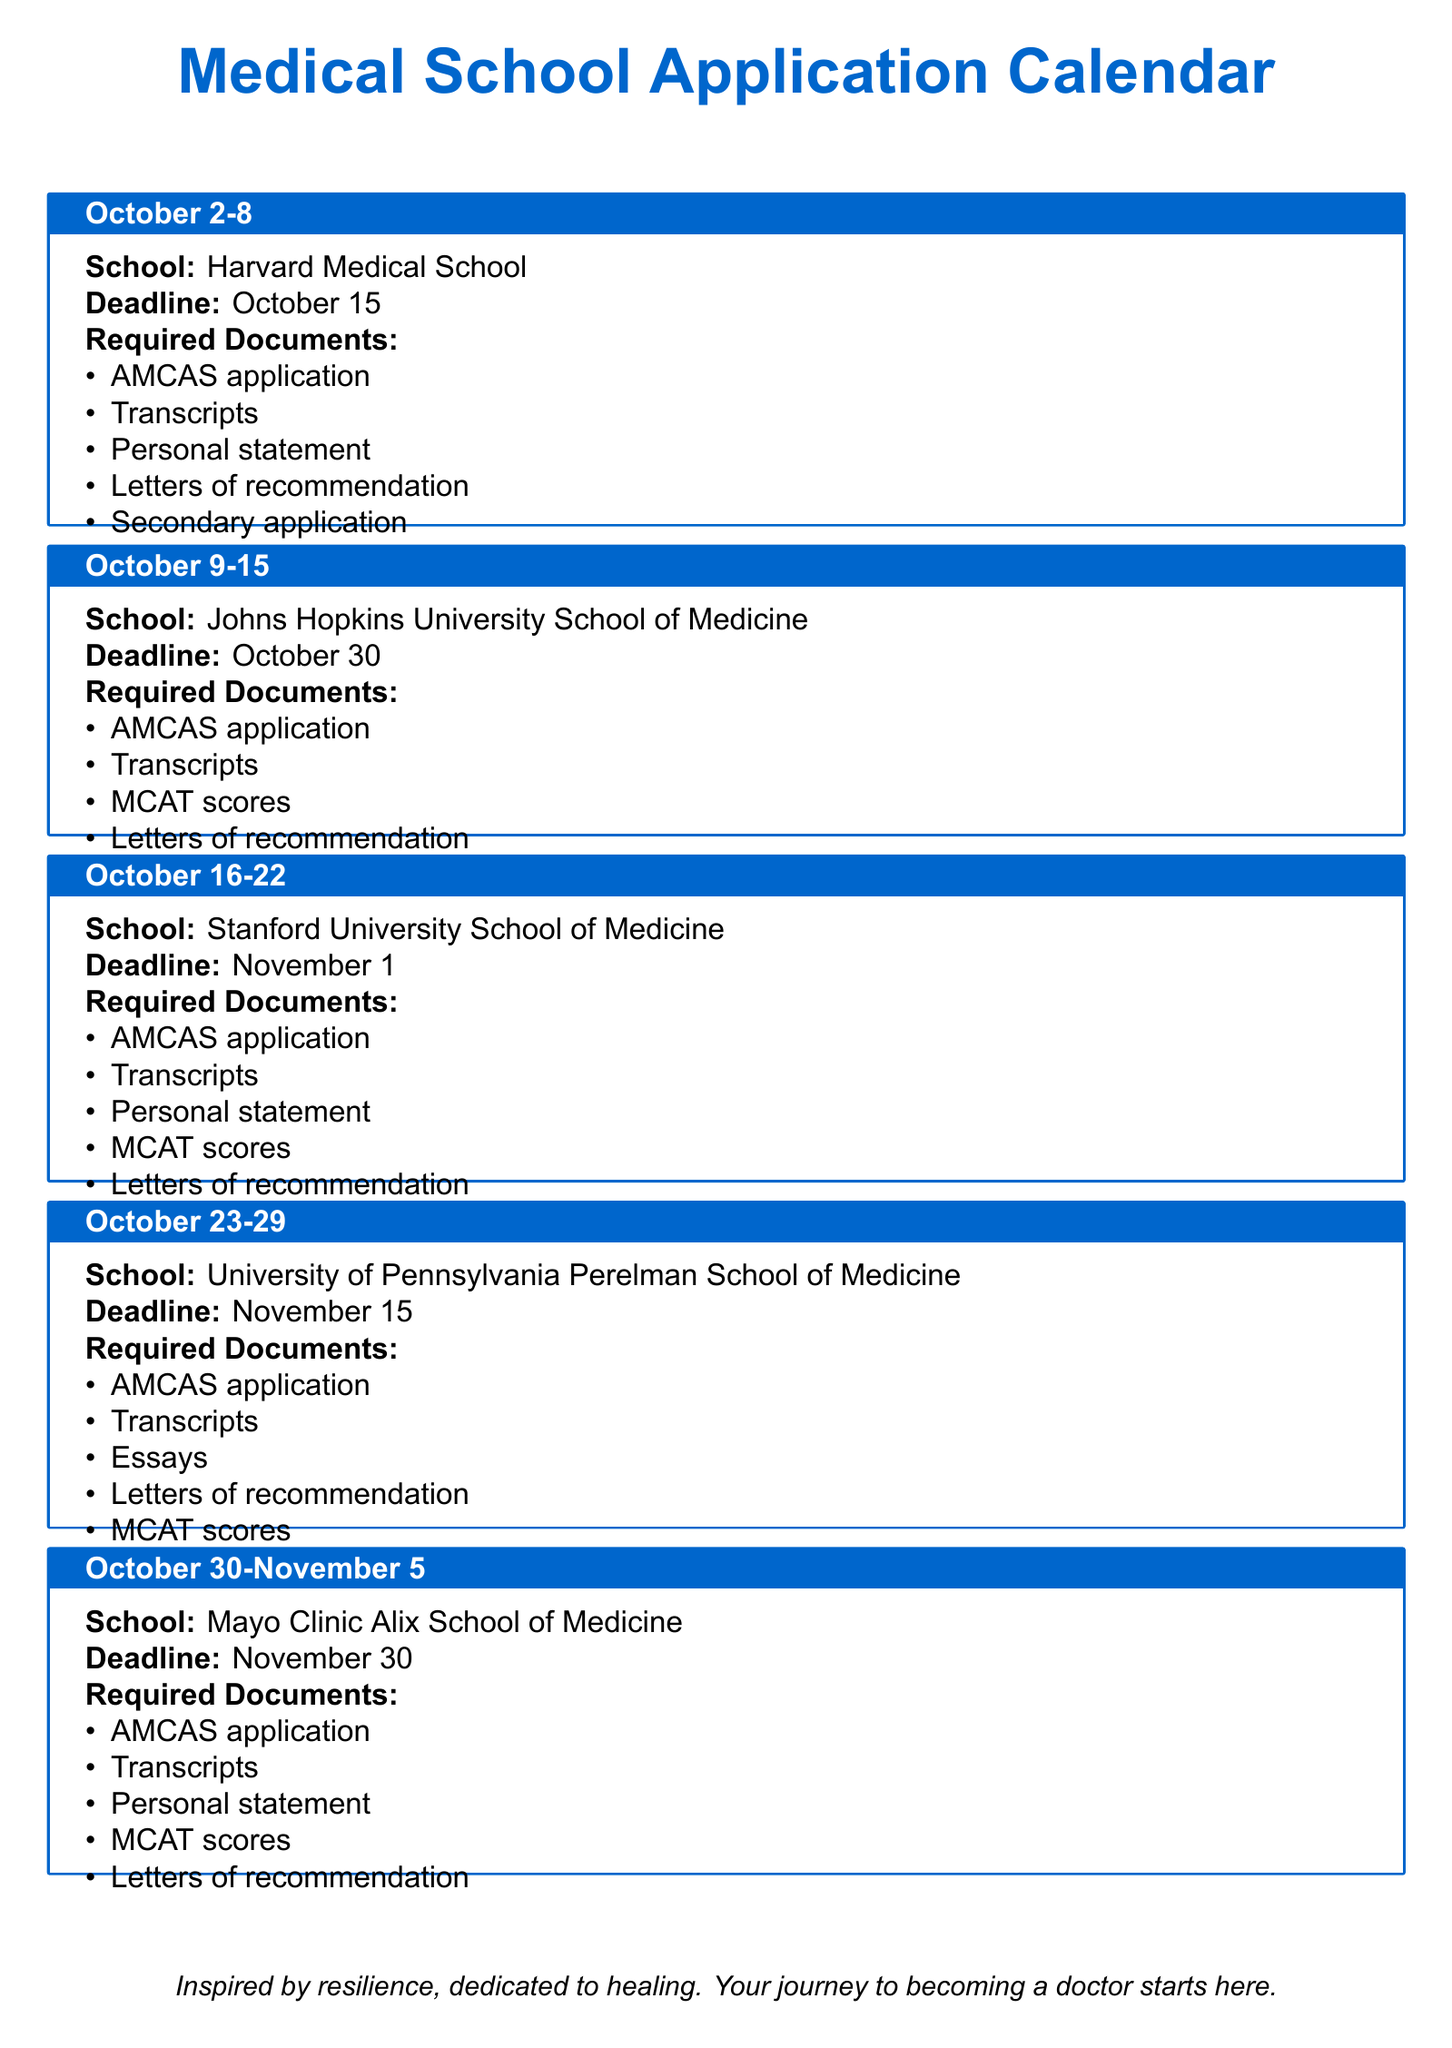What is the first deadline listed in the document? The first deadline is listed under Harvard Medical School, which is October 15.
Answer: October 15 How many documents are required for the Johns Hopkins University School of Medicine application? The document lists four required documents for Johns Hopkins University School of Medicine: AMCAS application, Transcripts, MCAT scores, and Letters of recommendation.
Answer: 4 Which medical school has a deadline on November 15? The University of Pennsylvania Perelman School of Medicine has a deadline on November 15.
Answer: University of Pennsylvania Perelman School of Medicine What type of application is required by Mayo Clinic Alix School of Medicine? The required application type for Mayo Clinic Alix School of Medicine is the AMCAS application.
Answer: AMCAS application Which school requires MCAT scores for its application? Stanford University School of Medicine and University of Pennsylvania Perelman School of Medicine both require MCAT scores for their applications.
Answer: Stanford University School of Medicine, University of Pennsylvania Perelman School of Medicine 